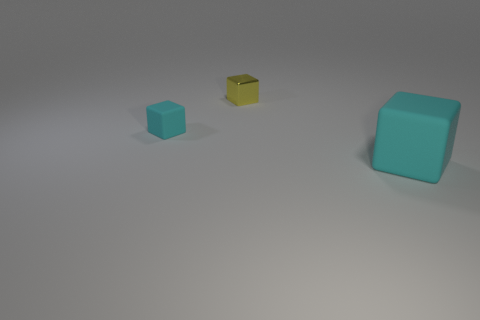Subtract 1 blocks. How many blocks are left? 2 Add 2 large yellow shiny objects. How many objects exist? 5 Add 3 tiny cyan matte blocks. How many tiny cyan matte blocks are left? 4 Add 1 big cyan matte cubes. How many big cyan matte cubes exist? 2 Subtract 0 green spheres. How many objects are left? 3 Subtract all large objects. Subtract all tiny purple matte cylinders. How many objects are left? 2 